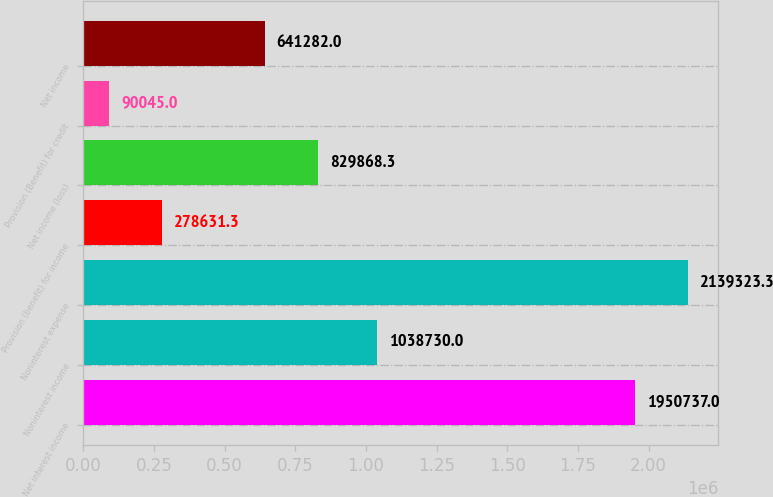<chart> <loc_0><loc_0><loc_500><loc_500><bar_chart><fcel>Net interest income<fcel>Noninterest income<fcel>Noninterest expense<fcel>Provision (benefit) for income<fcel>Net income (loss)<fcel>Provision (Benefit) for credit<fcel>Net income<nl><fcel>1.95074e+06<fcel>1.03873e+06<fcel>2.13932e+06<fcel>278631<fcel>829868<fcel>90045<fcel>641282<nl></chart> 